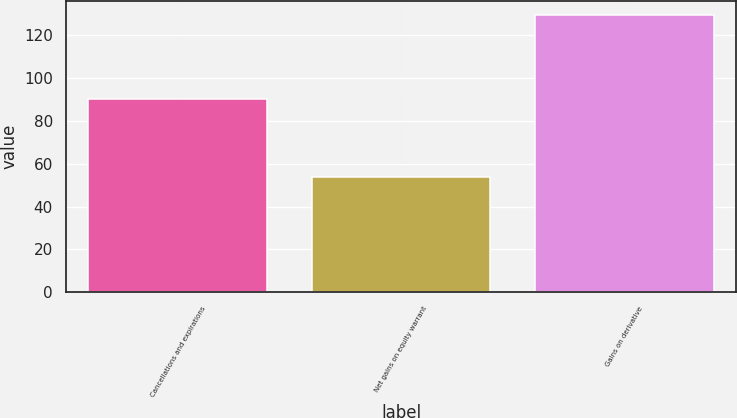Convert chart to OTSL. <chart><loc_0><loc_0><loc_500><loc_500><bar_chart><fcel>Cancellations and expirations<fcel>Net gains on equity warrant<fcel>Gains on derivative<nl><fcel>90.2<fcel>54<fcel>129.6<nl></chart> 